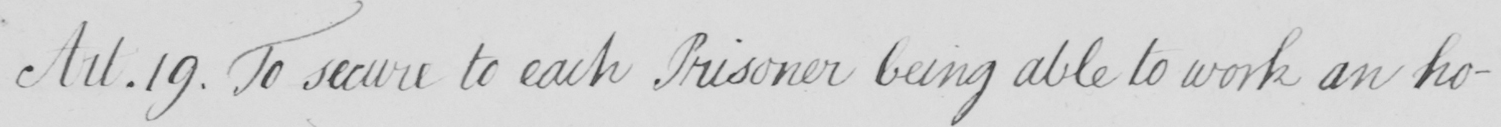Please transcribe the handwritten text in this image. Art . 19 . To secure to each Prisoner being able to work an ho- 